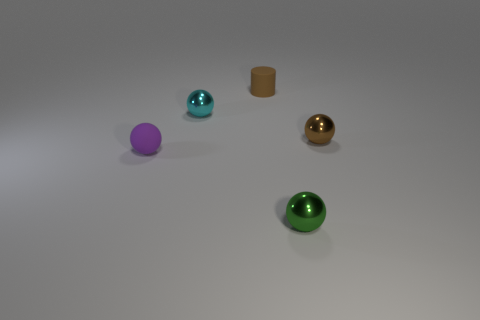Is there anything else that has the same shape as the brown matte thing?
Provide a short and direct response. No. The metallic thing behind the small sphere that is on the right side of the metal object in front of the tiny purple ball is what color?
Offer a very short reply. Cyan. What number of other things are there of the same material as the tiny green ball
Ensure brevity in your answer.  2. There is a tiny rubber thing behind the cyan ball; is its shape the same as the tiny green thing?
Your answer should be compact. No. How many large objects are green things or blue shiny balls?
Your answer should be very brief. 0. Are there an equal number of tiny brown matte objects behind the brown rubber object and cyan shiny balls right of the cyan ball?
Give a very brief answer. Yes. How many other things are the same color as the tiny cylinder?
Your answer should be very brief. 1. There is a tiny rubber cylinder; is it the same color as the tiny thing that is to the right of the green shiny thing?
Offer a terse response. Yes. How many cyan objects are big rubber objects or matte cylinders?
Your answer should be very brief. 0. Are there the same number of small green shiny objects that are behind the small cylinder and brown shiny spheres?
Make the answer very short. No. 